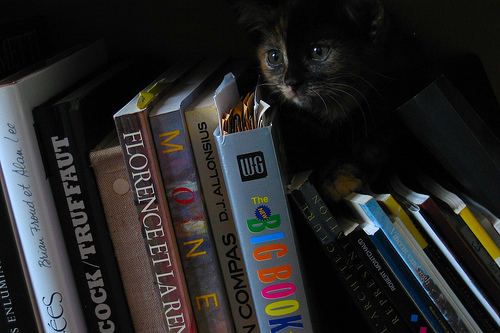Please identify all text content in this image. TRUFFAUT COCK FLORENCEE ETLA The CCS Brian Froud et Alan Lee REPRESESNATION REN BIG BOOK COMPAS D ALLONSIUS 